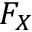<formula> <loc_0><loc_0><loc_500><loc_500>F _ { X }</formula> 